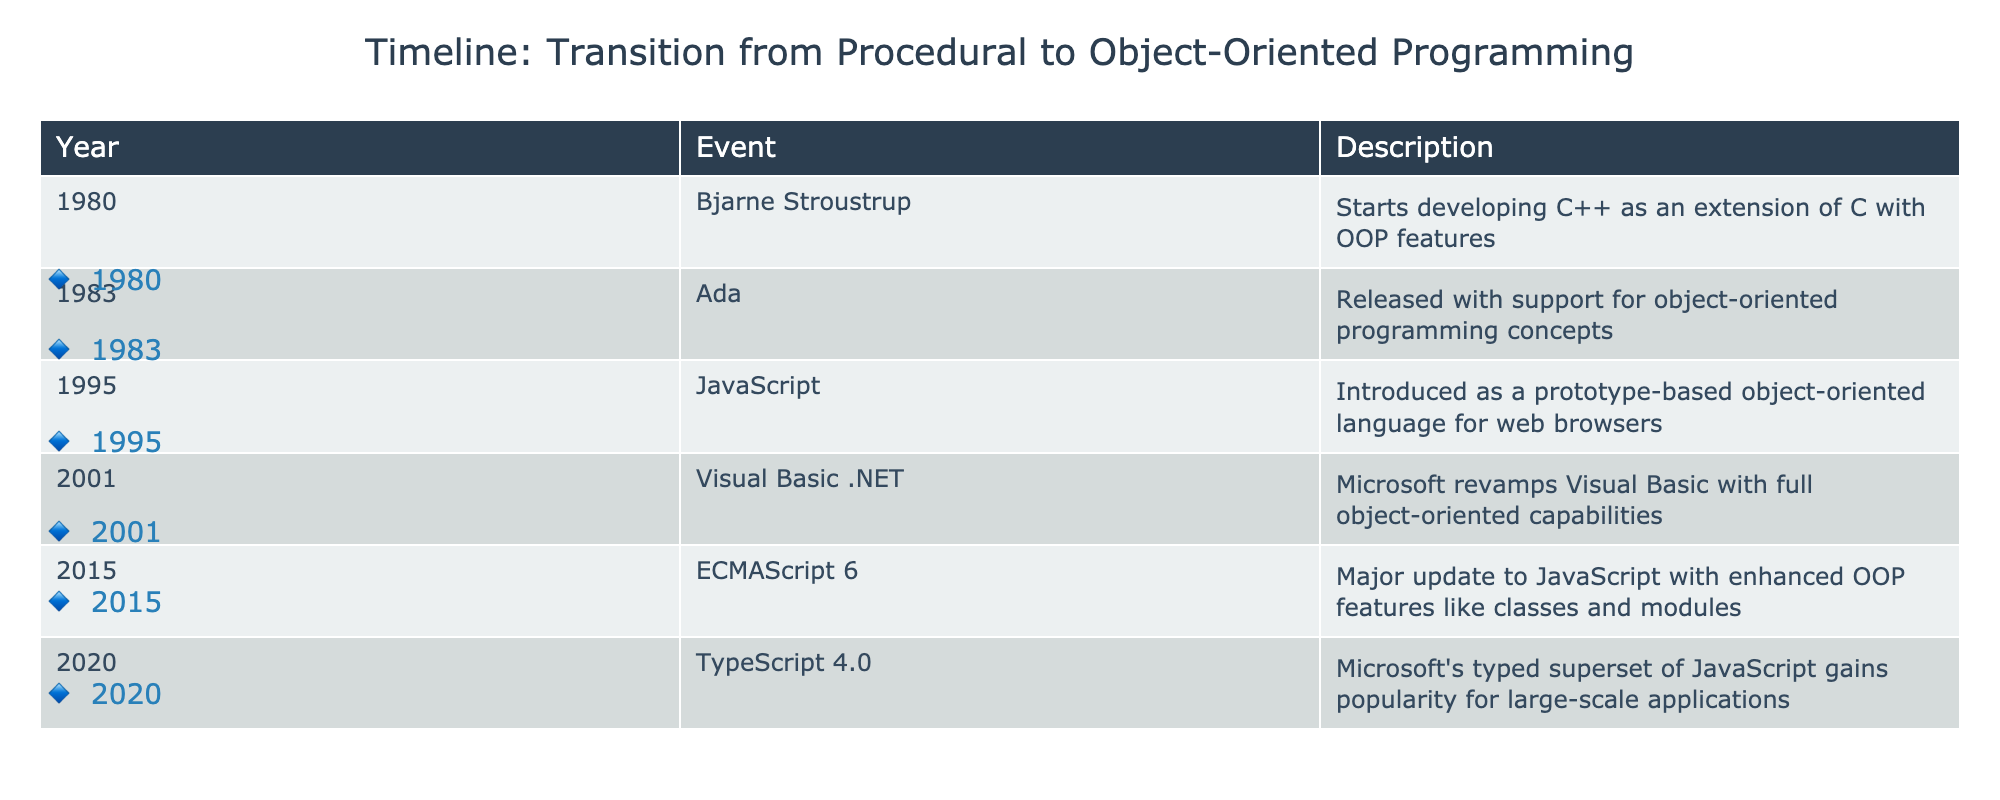What year did Bjarne Stroustrup start developing C++? The table lists the event for Bjarne Stroustrup under the year 1980.
Answer: 1980 Which programming language was introduced in 1995? The event in the year 1995 mentions JavaScript as the language that was introduced.
Answer: JavaScript How many events in the table occurred before 2000? By reviewing the years in the table, there are 5 entries (1980, 1983, 1995, 2001, 2015, 2020) and 4 of them occurred before 2000 (1980, 1983, 1995).
Answer: 4 Was Ada released after JavaScript? The table shows Ada released in 1983 and JavaScript in 1995, so Ada was released before JavaScript.
Answer: No What is the median year of the milestones listed in the table? The years in order are 1980, 1983, 1995, 2001, 2015, and 2020. The median is found by averaging the third (1995) and fourth elements (2001), which gives (1995 + 2001) / 2 = 1998.
Answer: 1998 Which programming language had its first major update in 2015 and what was significant about it? The table shows ECMAScript 6 in 2015; it had enhanced OOP features like classes and modules.
Answer: ECMAScript 6, major update with classes and modules In how many years after the release of Ada did C++ begin development? Ada was released in 1983, and C++ development started in 1980, which is 3 years before Ada's release.
Answer: 3 What percentage of events occurred after 2000? Out of the 6 events in the table, 2 events (2015 and 2020) occurred after 2000. This is 2 out of 6, giving a percentage of (2/6)*100 = 33.33%.
Answer: 33.33% 